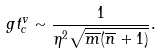<formula> <loc_0><loc_0><loc_500><loc_500>g t _ { c } ^ { v } \sim \frac { 1 } { \eta ^ { 2 } \sqrt { \overline { m } ( \overline { n } + 1 ) } } .</formula> 